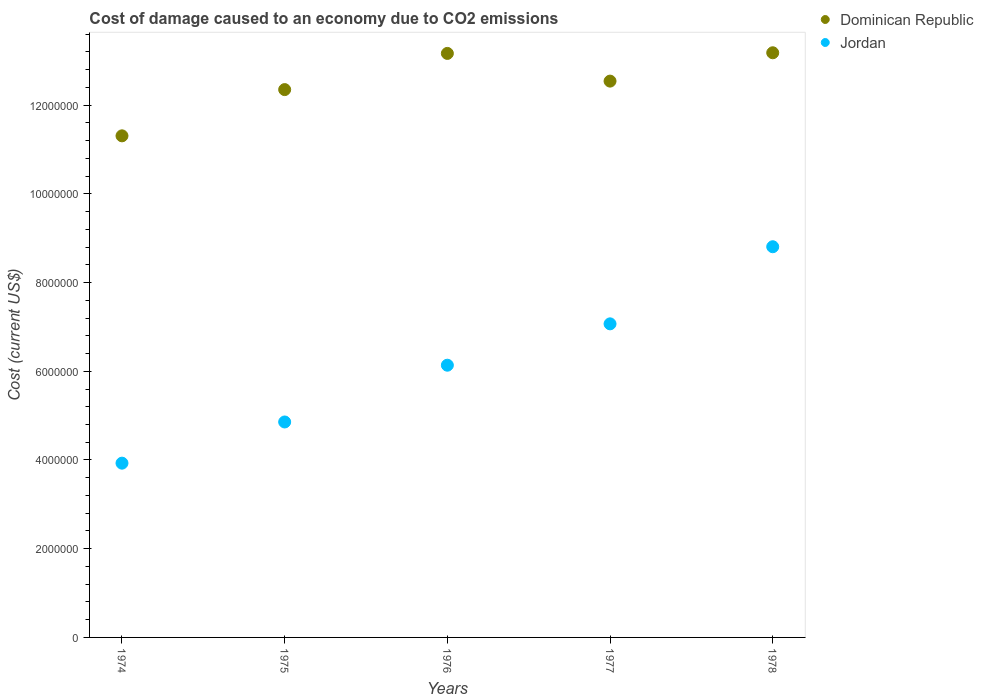How many different coloured dotlines are there?
Ensure brevity in your answer.  2. What is the cost of damage caused due to CO2 emissisons in Dominican Republic in 1976?
Keep it short and to the point. 1.32e+07. Across all years, what is the maximum cost of damage caused due to CO2 emissisons in Jordan?
Give a very brief answer. 8.81e+06. Across all years, what is the minimum cost of damage caused due to CO2 emissisons in Jordan?
Make the answer very short. 3.93e+06. In which year was the cost of damage caused due to CO2 emissisons in Dominican Republic maximum?
Offer a very short reply. 1978. In which year was the cost of damage caused due to CO2 emissisons in Dominican Republic minimum?
Offer a very short reply. 1974. What is the total cost of damage caused due to CO2 emissisons in Jordan in the graph?
Provide a short and direct response. 3.08e+07. What is the difference between the cost of damage caused due to CO2 emissisons in Jordan in 1974 and that in 1978?
Offer a very short reply. -4.88e+06. What is the difference between the cost of damage caused due to CO2 emissisons in Dominican Republic in 1976 and the cost of damage caused due to CO2 emissisons in Jordan in 1974?
Provide a succinct answer. 9.24e+06. What is the average cost of damage caused due to CO2 emissisons in Dominican Republic per year?
Provide a succinct answer. 1.25e+07. In the year 1976, what is the difference between the cost of damage caused due to CO2 emissisons in Jordan and cost of damage caused due to CO2 emissisons in Dominican Republic?
Your answer should be compact. -7.03e+06. What is the ratio of the cost of damage caused due to CO2 emissisons in Jordan in 1975 to that in 1977?
Give a very brief answer. 0.69. What is the difference between the highest and the second highest cost of damage caused due to CO2 emissisons in Dominican Republic?
Keep it short and to the point. 1.46e+04. What is the difference between the highest and the lowest cost of damage caused due to CO2 emissisons in Dominican Republic?
Provide a succinct answer. 1.87e+06. In how many years, is the cost of damage caused due to CO2 emissisons in Dominican Republic greater than the average cost of damage caused due to CO2 emissisons in Dominican Republic taken over all years?
Your response must be concise. 3. Is the sum of the cost of damage caused due to CO2 emissisons in Jordan in 1976 and 1978 greater than the maximum cost of damage caused due to CO2 emissisons in Dominican Republic across all years?
Keep it short and to the point. Yes. Is the cost of damage caused due to CO2 emissisons in Jordan strictly greater than the cost of damage caused due to CO2 emissisons in Dominican Republic over the years?
Provide a succinct answer. No. How many years are there in the graph?
Provide a short and direct response. 5. Are the values on the major ticks of Y-axis written in scientific E-notation?
Give a very brief answer. No. Does the graph contain any zero values?
Provide a succinct answer. No. Where does the legend appear in the graph?
Provide a short and direct response. Top right. What is the title of the graph?
Provide a short and direct response. Cost of damage caused to an economy due to CO2 emissions. Does "Tanzania" appear as one of the legend labels in the graph?
Offer a terse response. No. What is the label or title of the X-axis?
Make the answer very short. Years. What is the label or title of the Y-axis?
Keep it short and to the point. Cost (current US$). What is the Cost (current US$) of Dominican Republic in 1974?
Your answer should be compact. 1.13e+07. What is the Cost (current US$) in Jordan in 1974?
Offer a very short reply. 3.93e+06. What is the Cost (current US$) of Dominican Republic in 1975?
Ensure brevity in your answer.  1.23e+07. What is the Cost (current US$) in Jordan in 1975?
Make the answer very short. 4.86e+06. What is the Cost (current US$) in Dominican Republic in 1976?
Offer a very short reply. 1.32e+07. What is the Cost (current US$) of Jordan in 1976?
Ensure brevity in your answer.  6.14e+06. What is the Cost (current US$) in Dominican Republic in 1977?
Your response must be concise. 1.25e+07. What is the Cost (current US$) in Jordan in 1977?
Give a very brief answer. 7.07e+06. What is the Cost (current US$) in Dominican Republic in 1978?
Your answer should be compact. 1.32e+07. What is the Cost (current US$) of Jordan in 1978?
Provide a short and direct response. 8.81e+06. Across all years, what is the maximum Cost (current US$) of Dominican Republic?
Make the answer very short. 1.32e+07. Across all years, what is the maximum Cost (current US$) of Jordan?
Your response must be concise. 8.81e+06. Across all years, what is the minimum Cost (current US$) in Dominican Republic?
Your answer should be compact. 1.13e+07. Across all years, what is the minimum Cost (current US$) of Jordan?
Offer a terse response. 3.93e+06. What is the total Cost (current US$) of Dominican Republic in the graph?
Provide a succinct answer. 6.25e+07. What is the total Cost (current US$) in Jordan in the graph?
Provide a short and direct response. 3.08e+07. What is the difference between the Cost (current US$) of Dominican Republic in 1974 and that in 1975?
Make the answer very short. -1.04e+06. What is the difference between the Cost (current US$) of Jordan in 1974 and that in 1975?
Your response must be concise. -9.29e+05. What is the difference between the Cost (current US$) of Dominican Republic in 1974 and that in 1976?
Your answer should be very brief. -1.86e+06. What is the difference between the Cost (current US$) of Jordan in 1974 and that in 1976?
Give a very brief answer. -2.21e+06. What is the difference between the Cost (current US$) of Dominican Republic in 1974 and that in 1977?
Ensure brevity in your answer.  -1.23e+06. What is the difference between the Cost (current US$) of Jordan in 1974 and that in 1977?
Make the answer very short. -3.14e+06. What is the difference between the Cost (current US$) in Dominican Republic in 1974 and that in 1978?
Your answer should be compact. -1.87e+06. What is the difference between the Cost (current US$) of Jordan in 1974 and that in 1978?
Give a very brief answer. -4.88e+06. What is the difference between the Cost (current US$) of Dominican Republic in 1975 and that in 1976?
Your response must be concise. -8.16e+05. What is the difference between the Cost (current US$) of Jordan in 1975 and that in 1976?
Ensure brevity in your answer.  -1.28e+06. What is the difference between the Cost (current US$) in Dominican Republic in 1975 and that in 1977?
Your answer should be very brief. -1.91e+05. What is the difference between the Cost (current US$) of Jordan in 1975 and that in 1977?
Offer a very short reply. -2.21e+06. What is the difference between the Cost (current US$) in Dominican Republic in 1975 and that in 1978?
Your response must be concise. -8.30e+05. What is the difference between the Cost (current US$) in Jordan in 1975 and that in 1978?
Your answer should be compact. -3.95e+06. What is the difference between the Cost (current US$) of Dominican Republic in 1976 and that in 1977?
Your response must be concise. 6.25e+05. What is the difference between the Cost (current US$) in Jordan in 1976 and that in 1977?
Give a very brief answer. -9.32e+05. What is the difference between the Cost (current US$) in Dominican Republic in 1976 and that in 1978?
Your answer should be compact. -1.46e+04. What is the difference between the Cost (current US$) of Jordan in 1976 and that in 1978?
Your answer should be compact. -2.67e+06. What is the difference between the Cost (current US$) of Dominican Republic in 1977 and that in 1978?
Give a very brief answer. -6.39e+05. What is the difference between the Cost (current US$) in Jordan in 1977 and that in 1978?
Ensure brevity in your answer.  -1.74e+06. What is the difference between the Cost (current US$) in Dominican Republic in 1974 and the Cost (current US$) in Jordan in 1975?
Keep it short and to the point. 6.45e+06. What is the difference between the Cost (current US$) in Dominican Republic in 1974 and the Cost (current US$) in Jordan in 1976?
Your answer should be very brief. 5.17e+06. What is the difference between the Cost (current US$) in Dominican Republic in 1974 and the Cost (current US$) in Jordan in 1977?
Keep it short and to the point. 4.24e+06. What is the difference between the Cost (current US$) in Dominican Republic in 1974 and the Cost (current US$) in Jordan in 1978?
Keep it short and to the point. 2.50e+06. What is the difference between the Cost (current US$) of Dominican Republic in 1975 and the Cost (current US$) of Jordan in 1976?
Your answer should be compact. 6.21e+06. What is the difference between the Cost (current US$) of Dominican Republic in 1975 and the Cost (current US$) of Jordan in 1977?
Offer a very short reply. 5.28e+06. What is the difference between the Cost (current US$) in Dominican Republic in 1975 and the Cost (current US$) in Jordan in 1978?
Ensure brevity in your answer.  3.54e+06. What is the difference between the Cost (current US$) in Dominican Republic in 1976 and the Cost (current US$) in Jordan in 1977?
Provide a short and direct response. 6.10e+06. What is the difference between the Cost (current US$) of Dominican Republic in 1976 and the Cost (current US$) of Jordan in 1978?
Provide a short and direct response. 4.36e+06. What is the difference between the Cost (current US$) of Dominican Republic in 1977 and the Cost (current US$) of Jordan in 1978?
Your answer should be compact. 3.73e+06. What is the average Cost (current US$) of Dominican Republic per year?
Make the answer very short. 1.25e+07. What is the average Cost (current US$) of Jordan per year?
Make the answer very short. 6.16e+06. In the year 1974, what is the difference between the Cost (current US$) in Dominican Republic and Cost (current US$) in Jordan?
Give a very brief answer. 7.38e+06. In the year 1975, what is the difference between the Cost (current US$) of Dominican Republic and Cost (current US$) of Jordan?
Provide a short and direct response. 7.49e+06. In the year 1976, what is the difference between the Cost (current US$) in Dominican Republic and Cost (current US$) in Jordan?
Offer a terse response. 7.03e+06. In the year 1977, what is the difference between the Cost (current US$) of Dominican Republic and Cost (current US$) of Jordan?
Provide a succinct answer. 5.47e+06. In the year 1978, what is the difference between the Cost (current US$) in Dominican Republic and Cost (current US$) in Jordan?
Provide a succinct answer. 4.37e+06. What is the ratio of the Cost (current US$) of Dominican Republic in 1974 to that in 1975?
Your answer should be compact. 0.92. What is the ratio of the Cost (current US$) of Jordan in 1974 to that in 1975?
Offer a terse response. 0.81. What is the ratio of the Cost (current US$) of Dominican Republic in 1974 to that in 1976?
Offer a terse response. 0.86. What is the ratio of the Cost (current US$) of Jordan in 1974 to that in 1976?
Your answer should be compact. 0.64. What is the ratio of the Cost (current US$) of Dominican Republic in 1974 to that in 1977?
Your answer should be compact. 0.9. What is the ratio of the Cost (current US$) in Jordan in 1974 to that in 1977?
Your answer should be compact. 0.56. What is the ratio of the Cost (current US$) in Dominican Republic in 1974 to that in 1978?
Provide a short and direct response. 0.86. What is the ratio of the Cost (current US$) in Jordan in 1974 to that in 1978?
Ensure brevity in your answer.  0.45. What is the ratio of the Cost (current US$) of Dominican Republic in 1975 to that in 1976?
Offer a very short reply. 0.94. What is the ratio of the Cost (current US$) in Jordan in 1975 to that in 1976?
Give a very brief answer. 0.79. What is the ratio of the Cost (current US$) of Jordan in 1975 to that in 1977?
Your answer should be compact. 0.69. What is the ratio of the Cost (current US$) in Dominican Republic in 1975 to that in 1978?
Make the answer very short. 0.94. What is the ratio of the Cost (current US$) in Jordan in 1975 to that in 1978?
Provide a short and direct response. 0.55. What is the ratio of the Cost (current US$) in Dominican Republic in 1976 to that in 1977?
Your response must be concise. 1.05. What is the ratio of the Cost (current US$) of Jordan in 1976 to that in 1977?
Ensure brevity in your answer.  0.87. What is the ratio of the Cost (current US$) in Jordan in 1976 to that in 1978?
Make the answer very short. 0.7. What is the ratio of the Cost (current US$) in Dominican Republic in 1977 to that in 1978?
Provide a succinct answer. 0.95. What is the ratio of the Cost (current US$) of Jordan in 1977 to that in 1978?
Your response must be concise. 0.8. What is the difference between the highest and the second highest Cost (current US$) of Dominican Republic?
Give a very brief answer. 1.46e+04. What is the difference between the highest and the second highest Cost (current US$) in Jordan?
Provide a succinct answer. 1.74e+06. What is the difference between the highest and the lowest Cost (current US$) in Dominican Republic?
Ensure brevity in your answer.  1.87e+06. What is the difference between the highest and the lowest Cost (current US$) in Jordan?
Your answer should be very brief. 4.88e+06. 